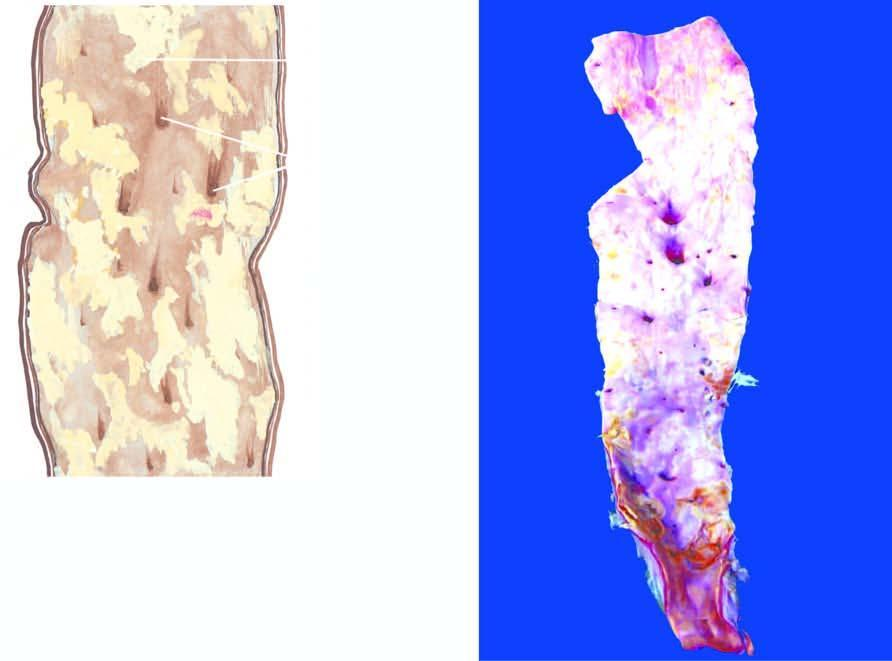what are narrowed by the atherosclerotic process?
Answer the question using a single word or phrase. Orifices of some of branches coming out of wall 